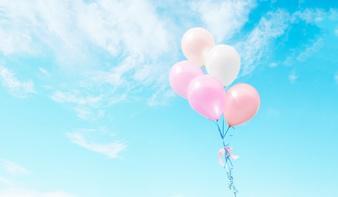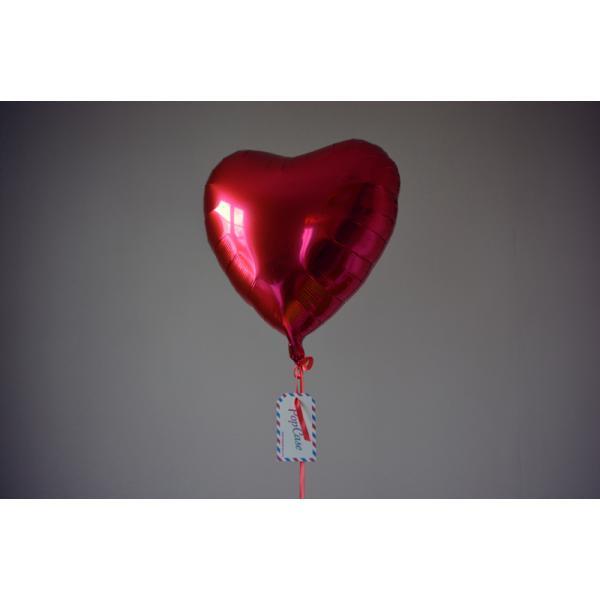The first image is the image on the left, the second image is the image on the right. Given the left and right images, does the statement "All images show more than six balloons in the air." hold true? Answer yes or no. No. The first image is the image on the left, the second image is the image on the right. For the images shown, is this caption "Both images show many different colored balloons against the blue sky." true? Answer yes or no. No. 